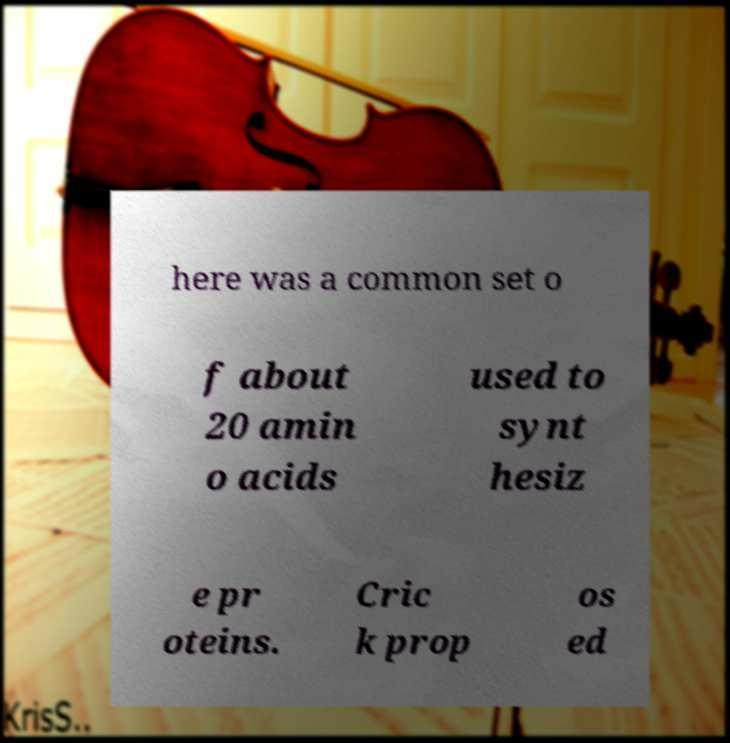Please identify and transcribe the text found in this image. here was a common set o f about 20 amin o acids used to synt hesiz e pr oteins. Cric k prop os ed 